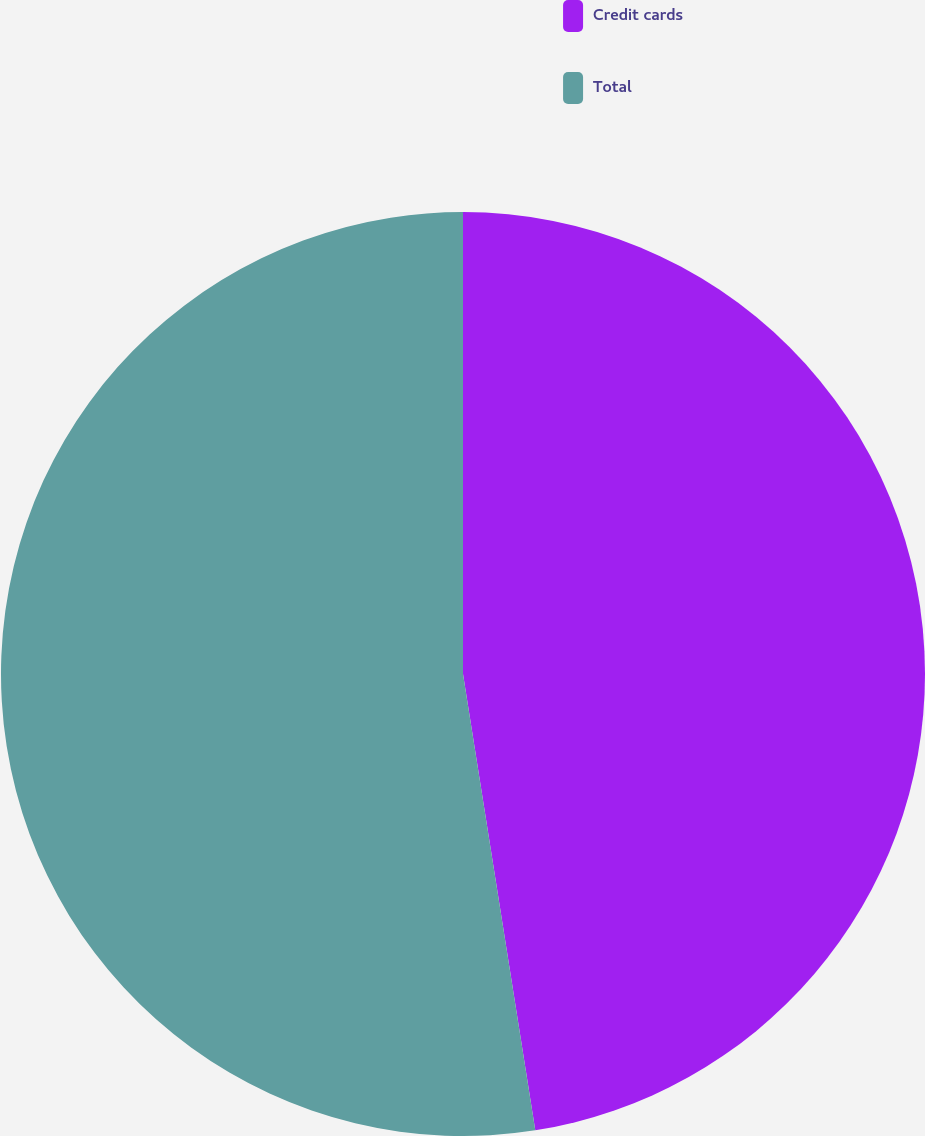<chart> <loc_0><loc_0><loc_500><loc_500><pie_chart><fcel>Credit cards<fcel>Total<nl><fcel>47.5%<fcel>52.5%<nl></chart> 